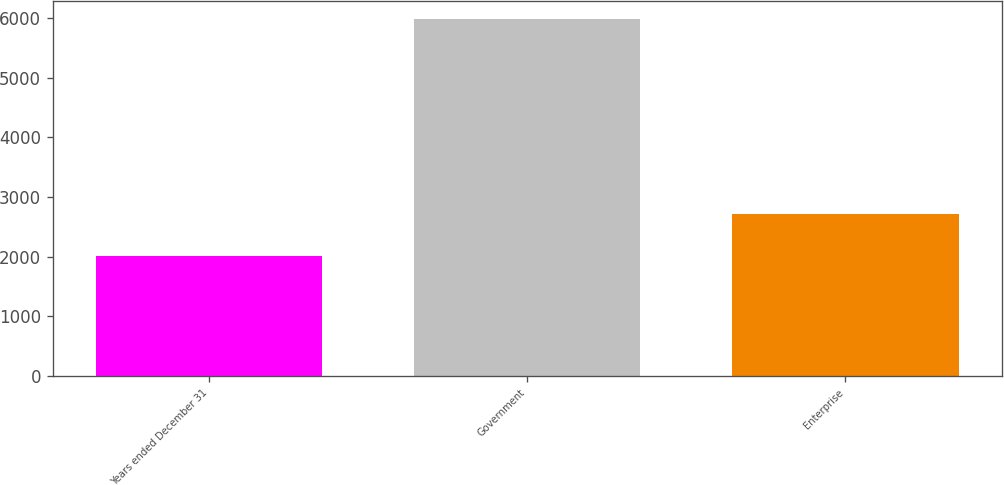Convert chart. <chart><loc_0><loc_0><loc_500><loc_500><bar_chart><fcel>Years ended December 31<fcel>Government<fcel>Enterprise<nl><fcel>2012<fcel>5989<fcel>2709<nl></chart> 